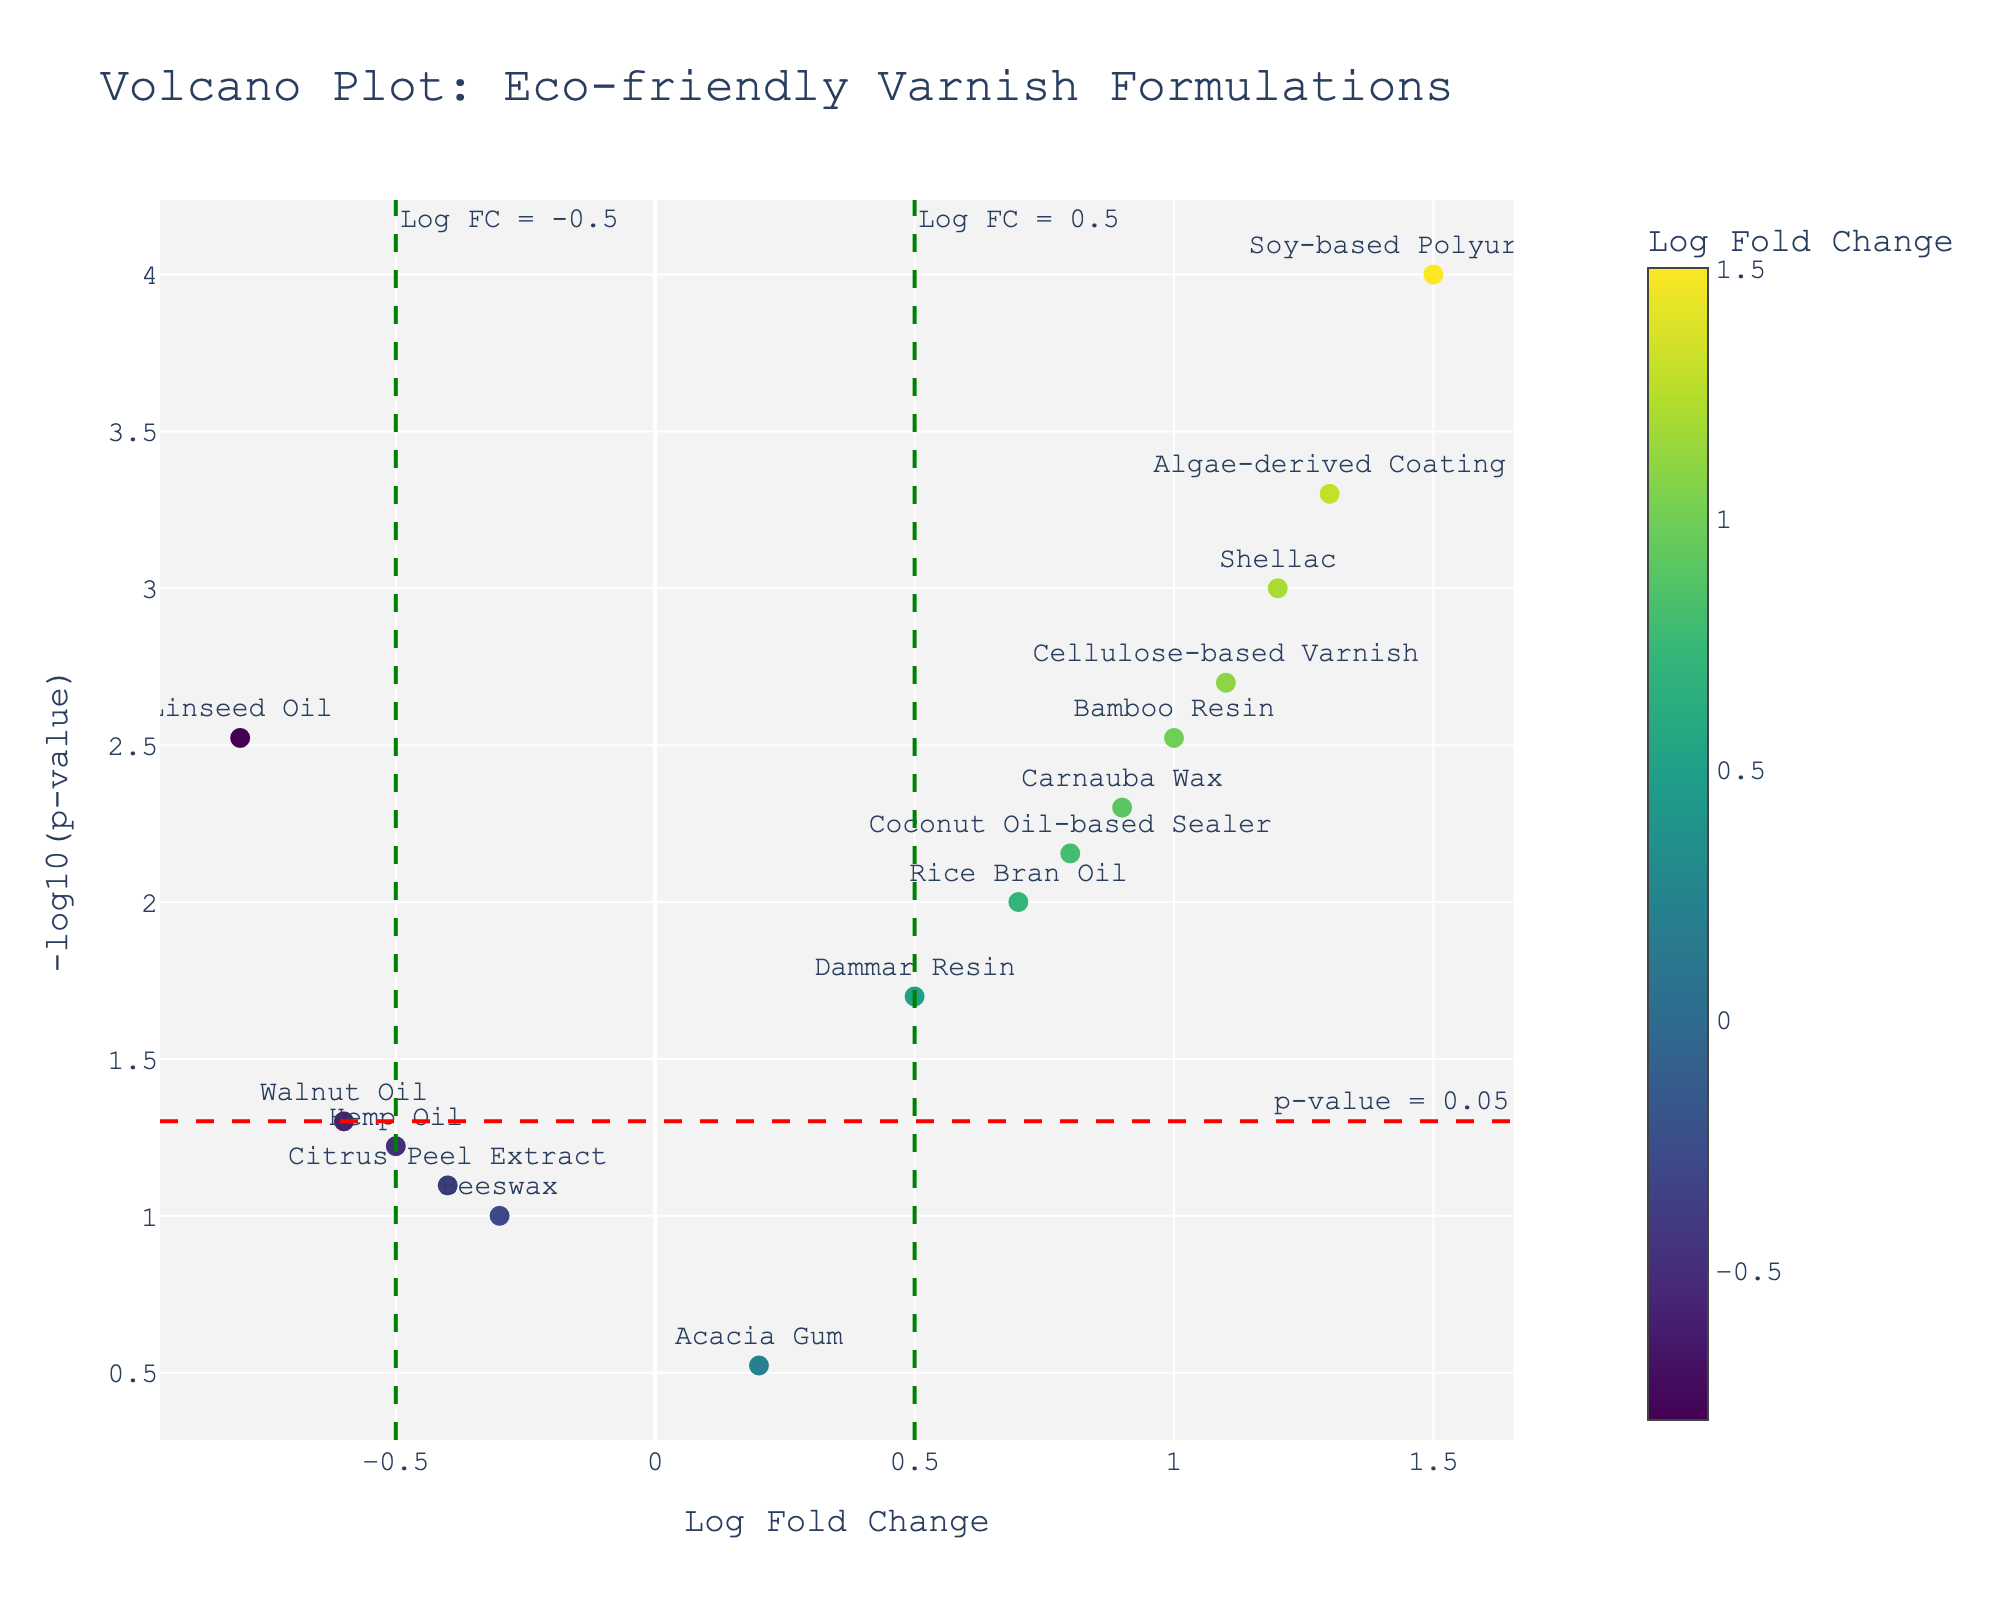What's the title of the plot? The title is usually at the top center of the plot. In this case, it is "Volcano Plot: Eco-friendly Varnish Formulations".
Answer: Volcano Plot: Eco-friendly Varnish Formulations Which varnish has the highest log fold change? Look for the varnish label at the data point with the highest log fold change value on the x-axis.
Answer: Soy-based Polyurethane What is the x-axis representing? The x-axis labels usually indicate what is being measured. In this case, it is labeled "Log Fold Change".
Answer: Log Fold Change How many data points are above the significance threshold of p = 0.05 (-log10(p-value) = 1.30)? Count the number of data points with a y-value (located above the horizontal dashed red line) greater than 1.30.
Answer: 11 Which varnish has the lowest p-value? P-value corresponds to the y-axis being -log10(p-value); the highest y-value represents the lowest p-value. Find the highest y-value and check the varnish label.
Answer: Soy-based Polyurethane How do Shellac and Walnut Oil compare in terms of log fold change? Compare the x-axis values of Shellac and Walnut Oil. Shellac is at 1.2, and Walnut Oil is at -0.6. Shellac has a higher log fold change.
Answer: Shellac has a higher log fold change than Walnut Oil What is the significance threshold indicated by the horizontal dashed red line? The horizontal dashed red line annotation shows the significance threshold line, indicating where p-value = 0.05 (-log10(p-value) = 1.30).
Answer: p = 0.05 Between Carnauba Wax and Rice Bran Oil, which one is more effective based on log fold change? Compare their x-axis values; Carnauba Wax is at 0.9, and Rice Bran Oil is at 0.7. Carnauba Wax has a higher log fold change.
Answer: Carnauba Wax How many varnishes have a log fold change greater than 0.5 and a p-value less than 0.05? Identify the data points in the regions where log fold change (x-axis) is greater than 0.5 and -log10(p-value) (y-axis) is greater than 1.30. Count these points.
Answer: 7 Which varnish falls within the non-significant region of the plot, based on the p-value threshold? Check for varnishes below the horizontal dashed red line (-log10(p-value) = 1.30). Beeswax and Acacia Gum fall below this threshold.
Answer: Beeswax, Acacia Gum 